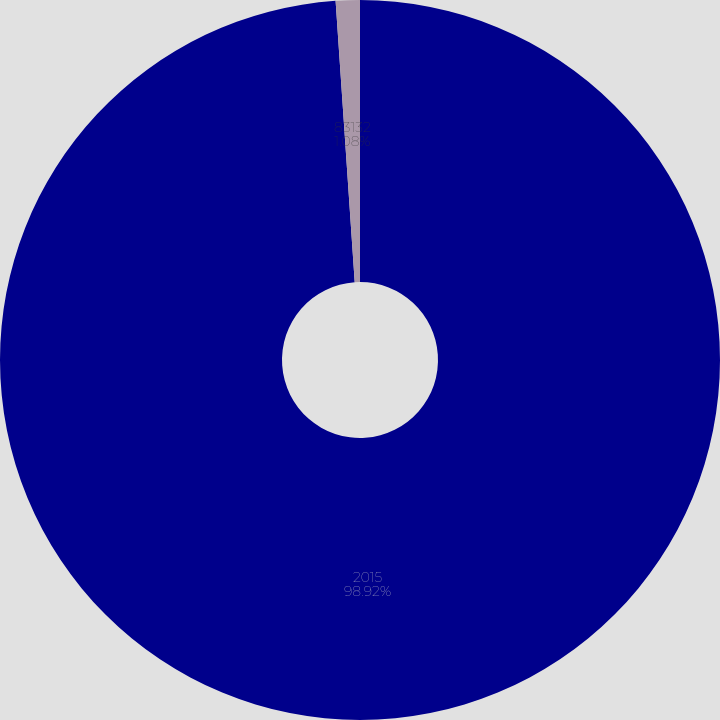<chart> <loc_0><loc_0><loc_500><loc_500><pie_chart><fcel>2015<fcel>83132<nl><fcel>98.92%<fcel>1.08%<nl></chart> 